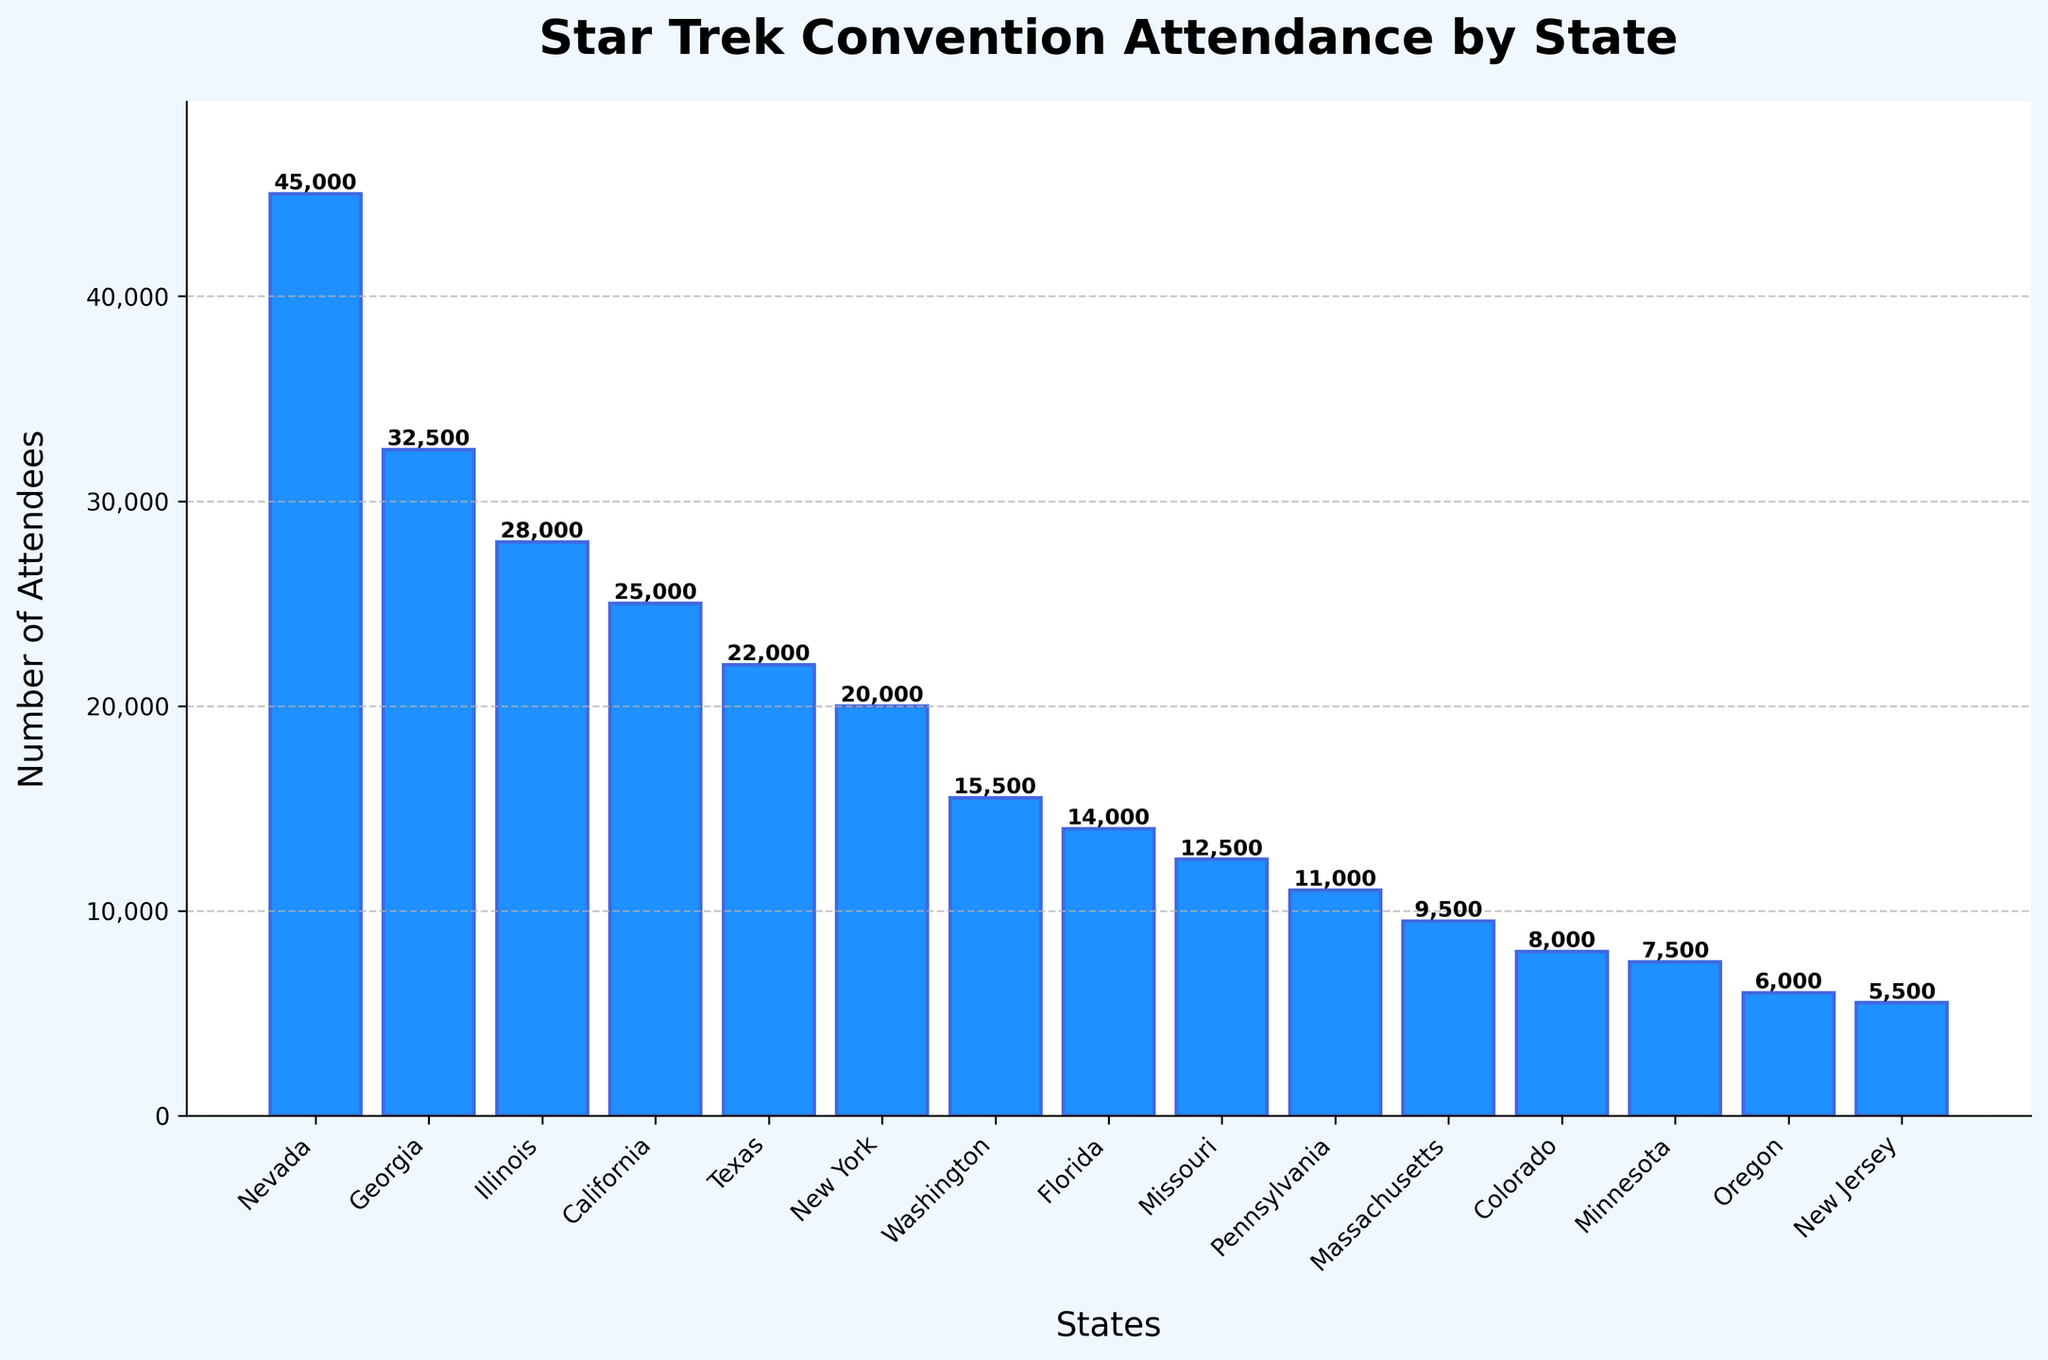Which state has the highest number of attendees? To find the state with the highest number of attendees, look for the tallest bar. The bar for Nevada is the tallest, indicating it has the most attendees.
Answer: Nevada What is the total number of attendees for Nevada and California combined? Add the number of attendees for Nevada (45,000) and California (25,000). The sum is 45,000 + 25,000 = 70,000.
Answer: 70,000 How many attendees are there in New York compared to Florida? Compare the heights of the bars for New York and Florida. The bar for New York shows 20,000 attendees, and the bar for Florida shows 14,000 attendees. The difference is 20,000 - 14,000 = 6,000.
Answer: 6,000 more Which state has fewer attendees: Colorado or Massachusetts? Compare the heights of the bars for Colorado and Massachusetts. The bar for Colorado has 8,000 attendees, while the bar for Massachusetts has 9,500 attendees. Therefore, Colorado has fewer attendees.
Answer: Colorado What is the average number of attendees across Texas, Illinois, and Georgia? Add the number of attendees for Texas (22,000), Illinois (28,000), and Georgia (32,500). The sum is 22,000 + 28,000 + 32,500 = 82,500. Divide by the number of states: 82,500 / 3 = 27,500.
Answer: 27,500 Which state has the lowest number of attendees? To find the state with the lowest number of attendees, look for the shortest bar. The shortest bar is for New Jersey, indicating it has the fewest attendees.
Answer: New Jersey What is the difference in attendance between the state with the most and the state with the least attendees? The state with the most attendees is Nevada (45,000) and the state with the least is New Jersey (5,500). The difference is 45,000 - 5,500 = 39,500.
Answer: 39,500 How do the attendees in Washington compare to those in Oregon? Compare the heights of the bars for Washington and Oregon. Washington has 15,500 attendees, and Oregon has 6,000 attendees. Washington has more attendees.
Answer: Washington If Oregon and New Jersey attendees are combined, would they have more than Massachusetts? Combine the attendees from Oregon (6,000) and New Jersey (5,500). The sum is 6,000 + 5,500 = 11,500. Massachusetts has 9,500 attendees, so 11,500 is more than 9,500.
Answer: Yes Which states have more than 20,000 attendees? Examine the bars to find states with attendees greater than 20,000. Nevada, Georgia, Illinois, and California have more than 20,000 attendees.
Answer: Nevada, Georgia, Illinois, California 